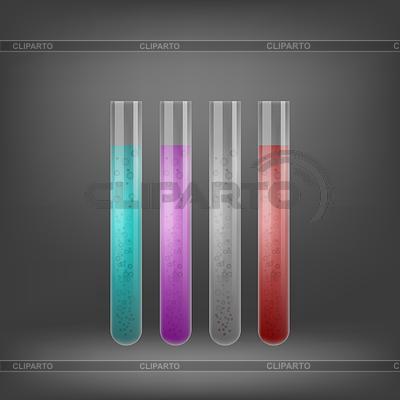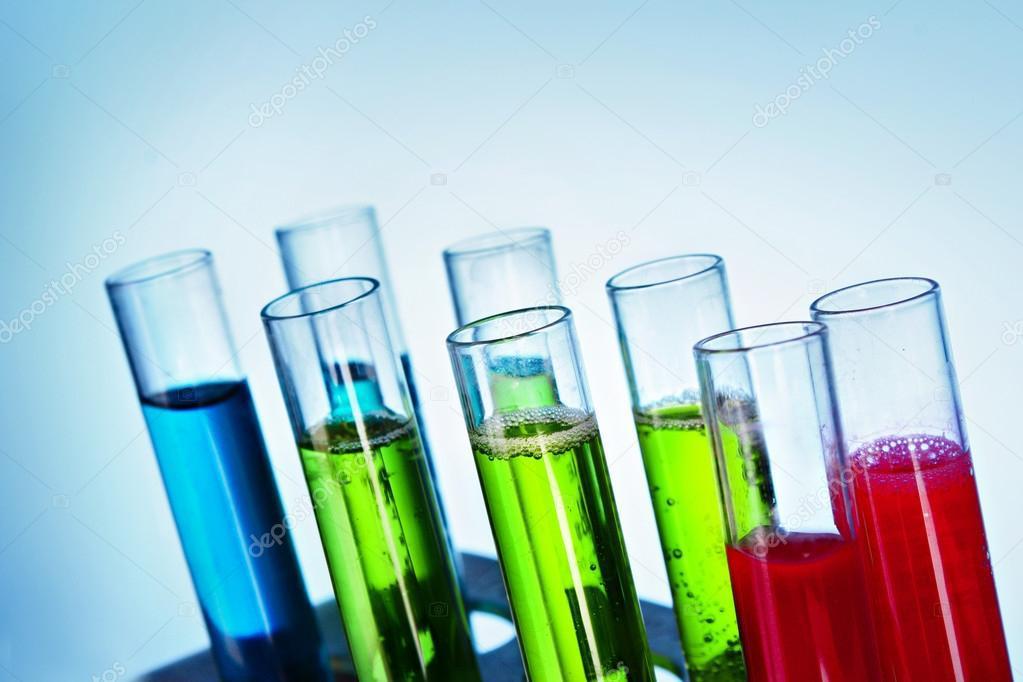The first image is the image on the left, the second image is the image on the right. For the images displayed, is the sentence "In one image there are five test tubes." factually correct? Answer yes or no. No. The first image is the image on the left, the second image is the image on the right. Examine the images to the left and right. Is the description "There are five test tubes in the left image." accurate? Answer yes or no. No. 